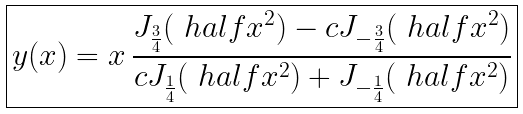Convert formula to latex. <formula><loc_0><loc_0><loc_500><loc_500>\boxed { y ( x ) = x \, \frac { J _ { \frac { 3 } { 4 } } ( \ h a l f x ^ { 2 } ) - c J _ { - \frac { 3 } { 4 } } ( \ h a l f x ^ { 2 } ) } { c J _ { \frac { 1 } { 4 } } ( \ h a l f x ^ { 2 } ) + J _ { - \frac { 1 } { 4 } } ( \ h a l f x ^ { 2 } ) } }</formula> 